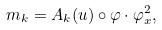Convert formula to latex. <formula><loc_0><loc_0><loc_500><loc_500>m _ { k } = A _ { k } ( u ) \circ \varphi \cdot \varphi _ { x } ^ { 2 } ,</formula> 